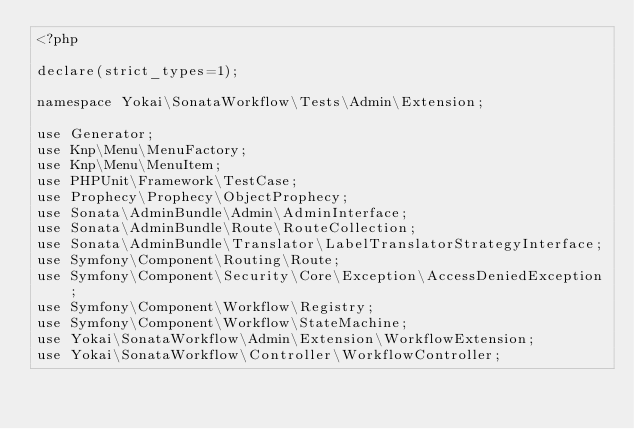<code> <loc_0><loc_0><loc_500><loc_500><_PHP_><?php

declare(strict_types=1);

namespace Yokai\SonataWorkflow\Tests\Admin\Extension;

use Generator;
use Knp\Menu\MenuFactory;
use Knp\Menu\MenuItem;
use PHPUnit\Framework\TestCase;
use Prophecy\Prophecy\ObjectProphecy;
use Sonata\AdminBundle\Admin\AdminInterface;
use Sonata\AdminBundle\Route\RouteCollection;
use Sonata\AdminBundle\Translator\LabelTranslatorStrategyInterface;
use Symfony\Component\Routing\Route;
use Symfony\Component\Security\Core\Exception\AccessDeniedException;
use Symfony\Component\Workflow\Registry;
use Symfony\Component\Workflow\StateMachine;
use Yokai\SonataWorkflow\Admin\Extension\WorkflowExtension;
use Yokai\SonataWorkflow\Controller\WorkflowController;</code> 